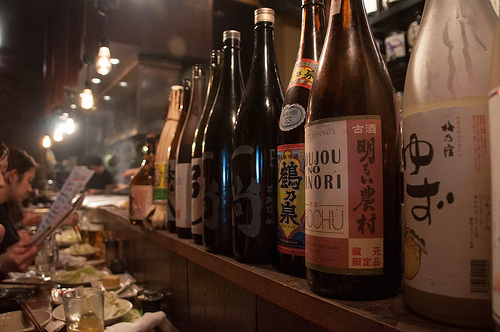<image>
Is there a bottle above the shelf? No. The bottle is not positioned above the shelf. The vertical arrangement shows a different relationship. 